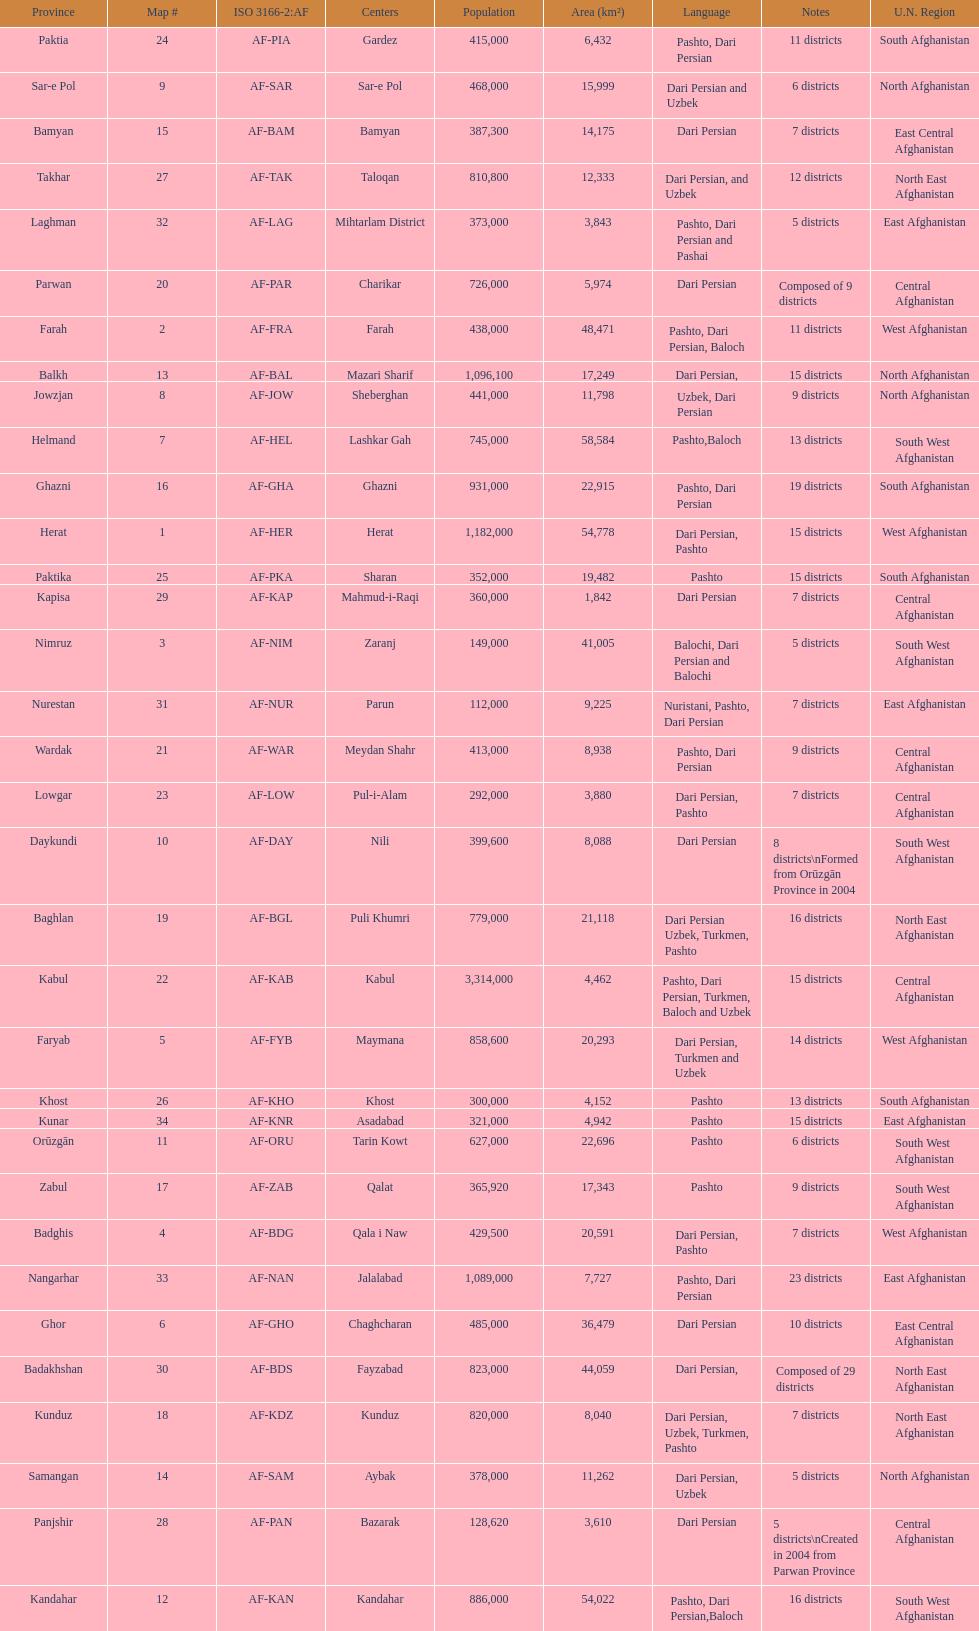Which province has the most districts? Badakhshan. 